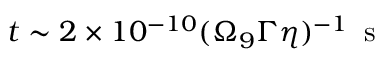<formula> <loc_0><loc_0><loc_500><loc_500>t \sim 2 \times 1 0 ^ { - 1 0 } ( \Omega _ { 9 } \Gamma \eta ) ^ { - 1 } \, s</formula> 